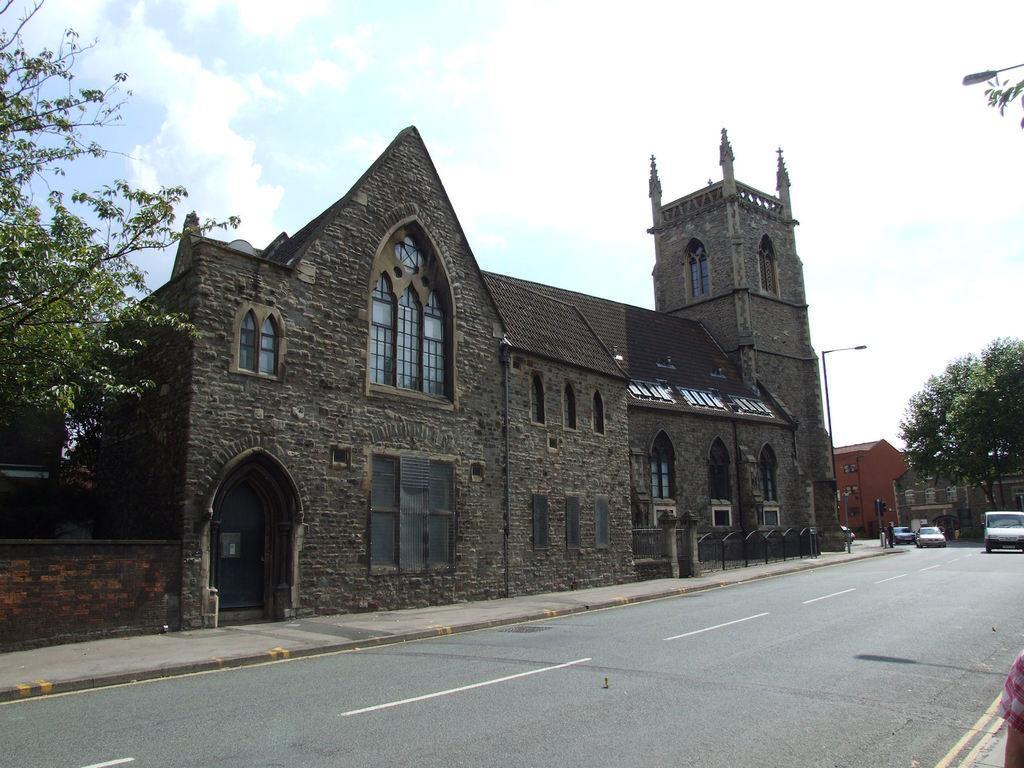In one or two sentences, can you explain what this image depicts? In this picture we can see cars on the road, trees, buildings with windows and in the background we can see the sky with clouds. 